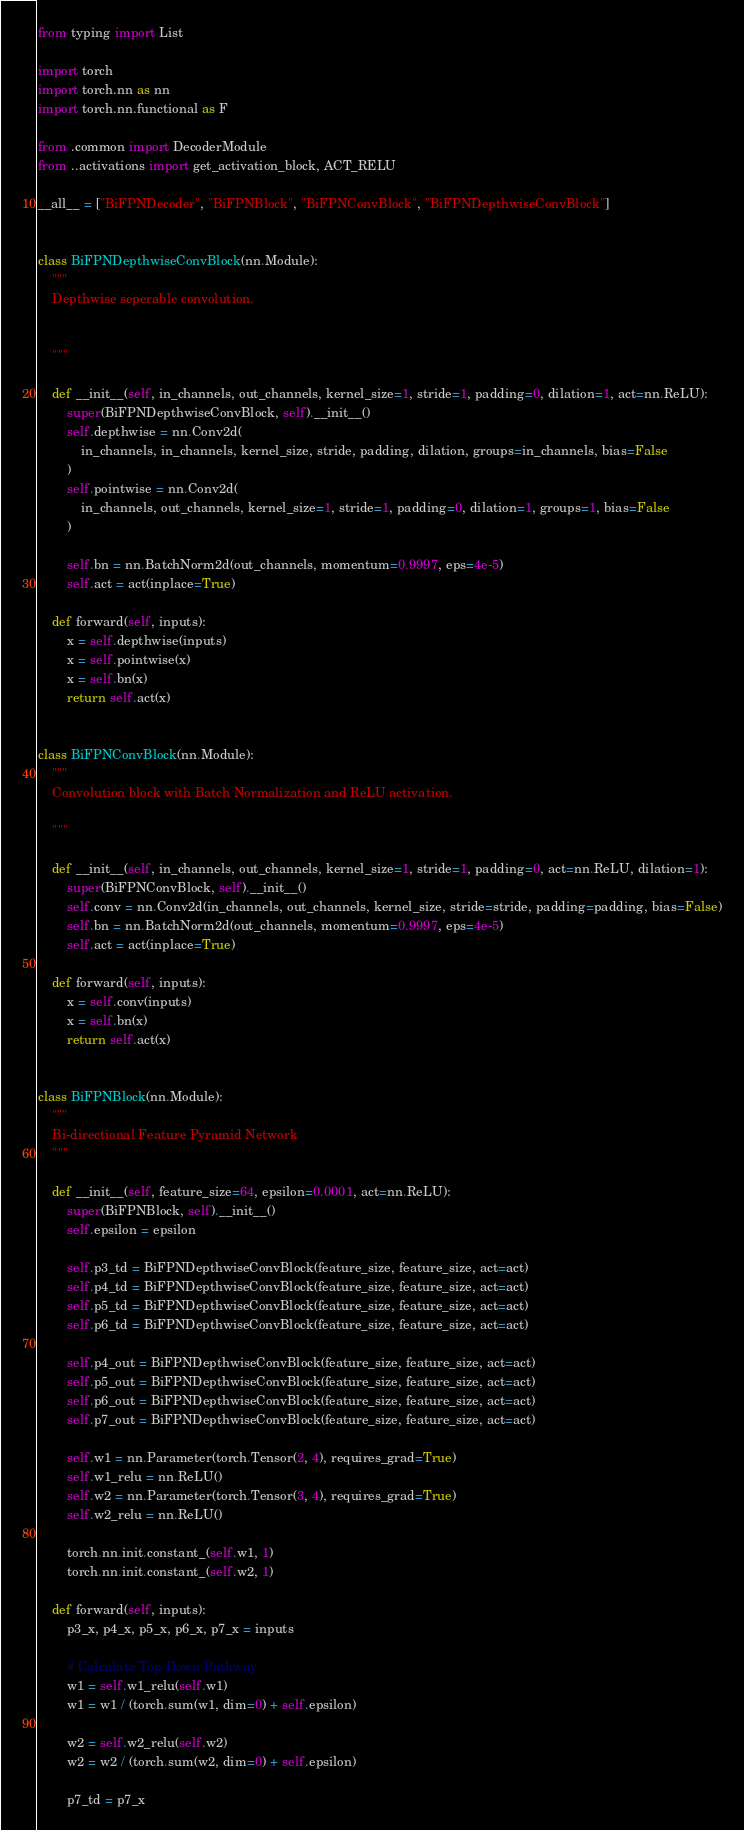<code> <loc_0><loc_0><loc_500><loc_500><_Python_>from typing import List

import torch
import torch.nn as nn
import torch.nn.functional as F

from .common import DecoderModule
from ..activations import get_activation_block, ACT_RELU

__all__ = ["BiFPNDecoder", "BiFPNBlock", "BiFPNConvBlock", "BiFPNDepthwiseConvBlock"]


class BiFPNDepthwiseConvBlock(nn.Module):
    """
    Depthwise seperable convolution.


    """

    def __init__(self, in_channels, out_channels, kernel_size=1, stride=1, padding=0, dilation=1, act=nn.ReLU):
        super(BiFPNDepthwiseConvBlock, self).__init__()
        self.depthwise = nn.Conv2d(
            in_channels, in_channels, kernel_size, stride, padding, dilation, groups=in_channels, bias=False
        )
        self.pointwise = nn.Conv2d(
            in_channels, out_channels, kernel_size=1, stride=1, padding=0, dilation=1, groups=1, bias=False
        )

        self.bn = nn.BatchNorm2d(out_channels, momentum=0.9997, eps=4e-5)
        self.act = act(inplace=True)

    def forward(self, inputs):
        x = self.depthwise(inputs)
        x = self.pointwise(x)
        x = self.bn(x)
        return self.act(x)


class BiFPNConvBlock(nn.Module):
    """
    Convolution block with Batch Normalization and ReLU activation.

    """

    def __init__(self, in_channels, out_channels, kernel_size=1, stride=1, padding=0, act=nn.ReLU, dilation=1):
        super(BiFPNConvBlock, self).__init__()
        self.conv = nn.Conv2d(in_channels, out_channels, kernel_size, stride=stride, padding=padding, bias=False)
        self.bn = nn.BatchNorm2d(out_channels, momentum=0.9997, eps=4e-5)
        self.act = act(inplace=True)

    def forward(self, inputs):
        x = self.conv(inputs)
        x = self.bn(x)
        return self.act(x)


class BiFPNBlock(nn.Module):
    """
    Bi-directional Feature Pyramid Network
    """

    def __init__(self, feature_size=64, epsilon=0.0001, act=nn.ReLU):
        super(BiFPNBlock, self).__init__()
        self.epsilon = epsilon

        self.p3_td = BiFPNDepthwiseConvBlock(feature_size, feature_size, act=act)
        self.p4_td = BiFPNDepthwiseConvBlock(feature_size, feature_size, act=act)
        self.p5_td = BiFPNDepthwiseConvBlock(feature_size, feature_size, act=act)
        self.p6_td = BiFPNDepthwiseConvBlock(feature_size, feature_size, act=act)

        self.p4_out = BiFPNDepthwiseConvBlock(feature_size, feature_size, act=act)
        self.p5_out = BiFPNDepthwiseConvBlock(feature_size, feature_size, act=act)
        self.p6_out = BiFPNDepthwiseConvBlock(feature_size, feature_size, act=act)
        self.p7_out = BiFPNDepthwiseConvBlock(feature_size, feature_size, act=act)

        self.w1 = nn.Parameter(torch.Tensor(2, 4), requires_grad=True)
        self.w1_relu = nn.ReLU()
        self.w2 = nn.Parameter(torch.Tensor(3, 4), requires_grad=True)
        self.w2_relu = nn.ReLU()

        torch.nn.init.constant_(self.w1, 1)
        torch.nn.init.constant_(self.w2, 1)

    def forward(self, inputs):
        p3_x, p4_x, p5_x, p6_x, p7_x = inputs

        # Calculate Top-Down Pathway
        w1 = self.w1_relu(self.w1)
        w1 = w1 / (torch.sum(w1, dim=0) + self.epsilon)

        w2 = self.w2_relu(self.w2)
        w2 = w2 / (torch.sum(w2, dim=0) + self.epsilon)

        p7_td = p7_x</code> 